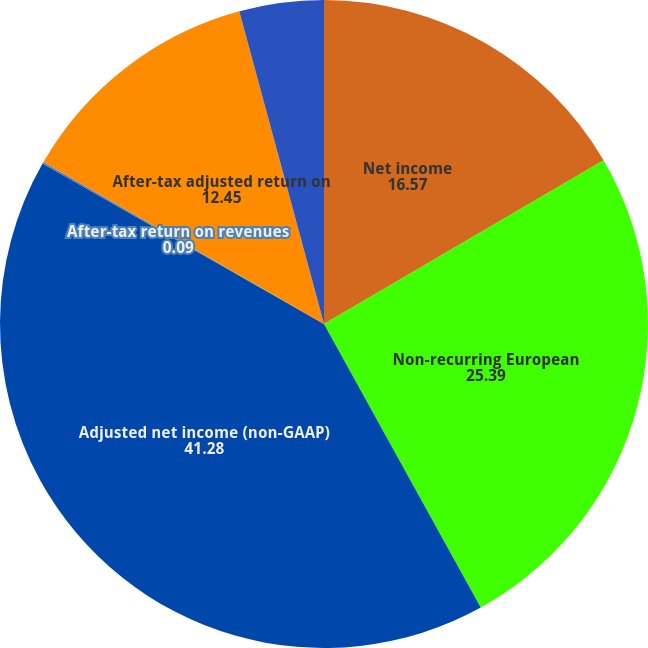Convert chart to OTSL. <chart><loc_0><loc_0><loc_500><loc_500><pie_chart><fcel>Net income<fcel>Non-recurring European<fcel>Adjusted net income (non-GAAP)<fcel>After-tax return on revenues<fcel>After-tax adjusted return on<fcel>After-tax return on beginning<nl><fcel>16.57%<fcel>25.39%<fcel>41.28%<fcel>0.09%<fcel>12.45%<fcel>4.21%<nl></chart> 